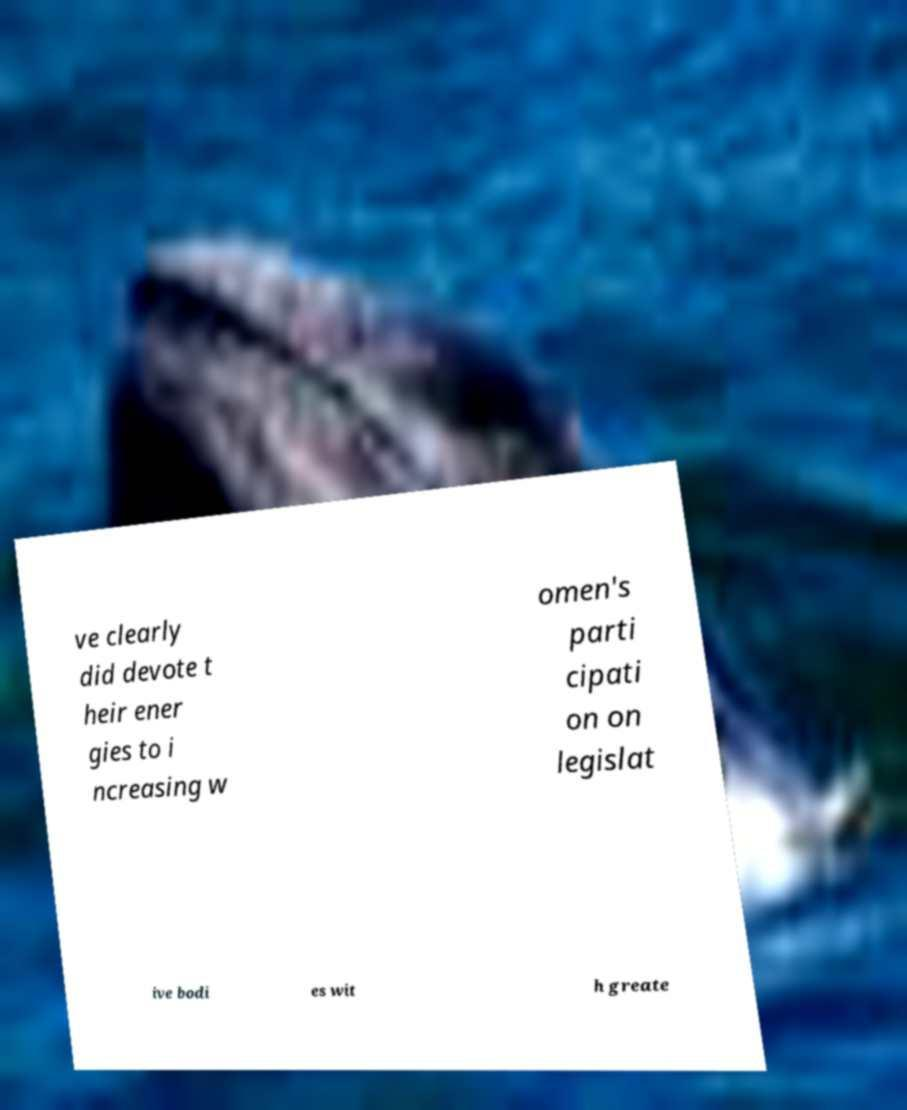For documentation purposes, I need the text within this image transcribed. Could you provide that? ve clearly did devote t heir ener gies to i ncreasing w omen's parti cipati on on legislat ive bodi es wit h greate 